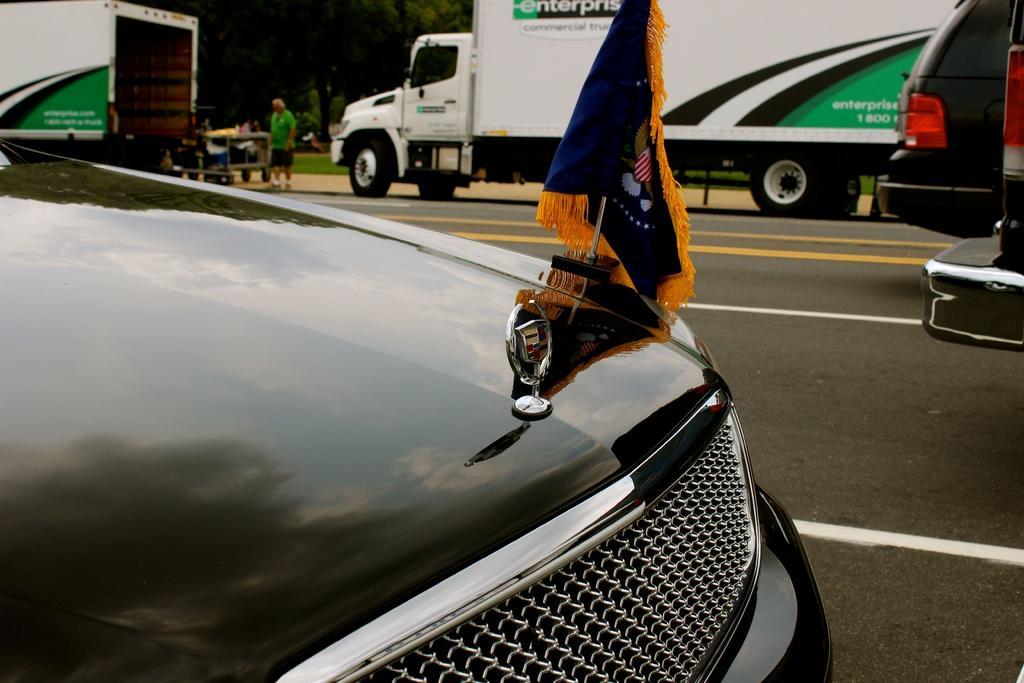In one or two sentences, can you explain what this image depicts? In this image I can see few vehicles on the road. These vehicles are in different color. And I can see the flag to one of the vehicle. At the back there is a person standing and wearing the green color dress. I can also see many trees in the back. 